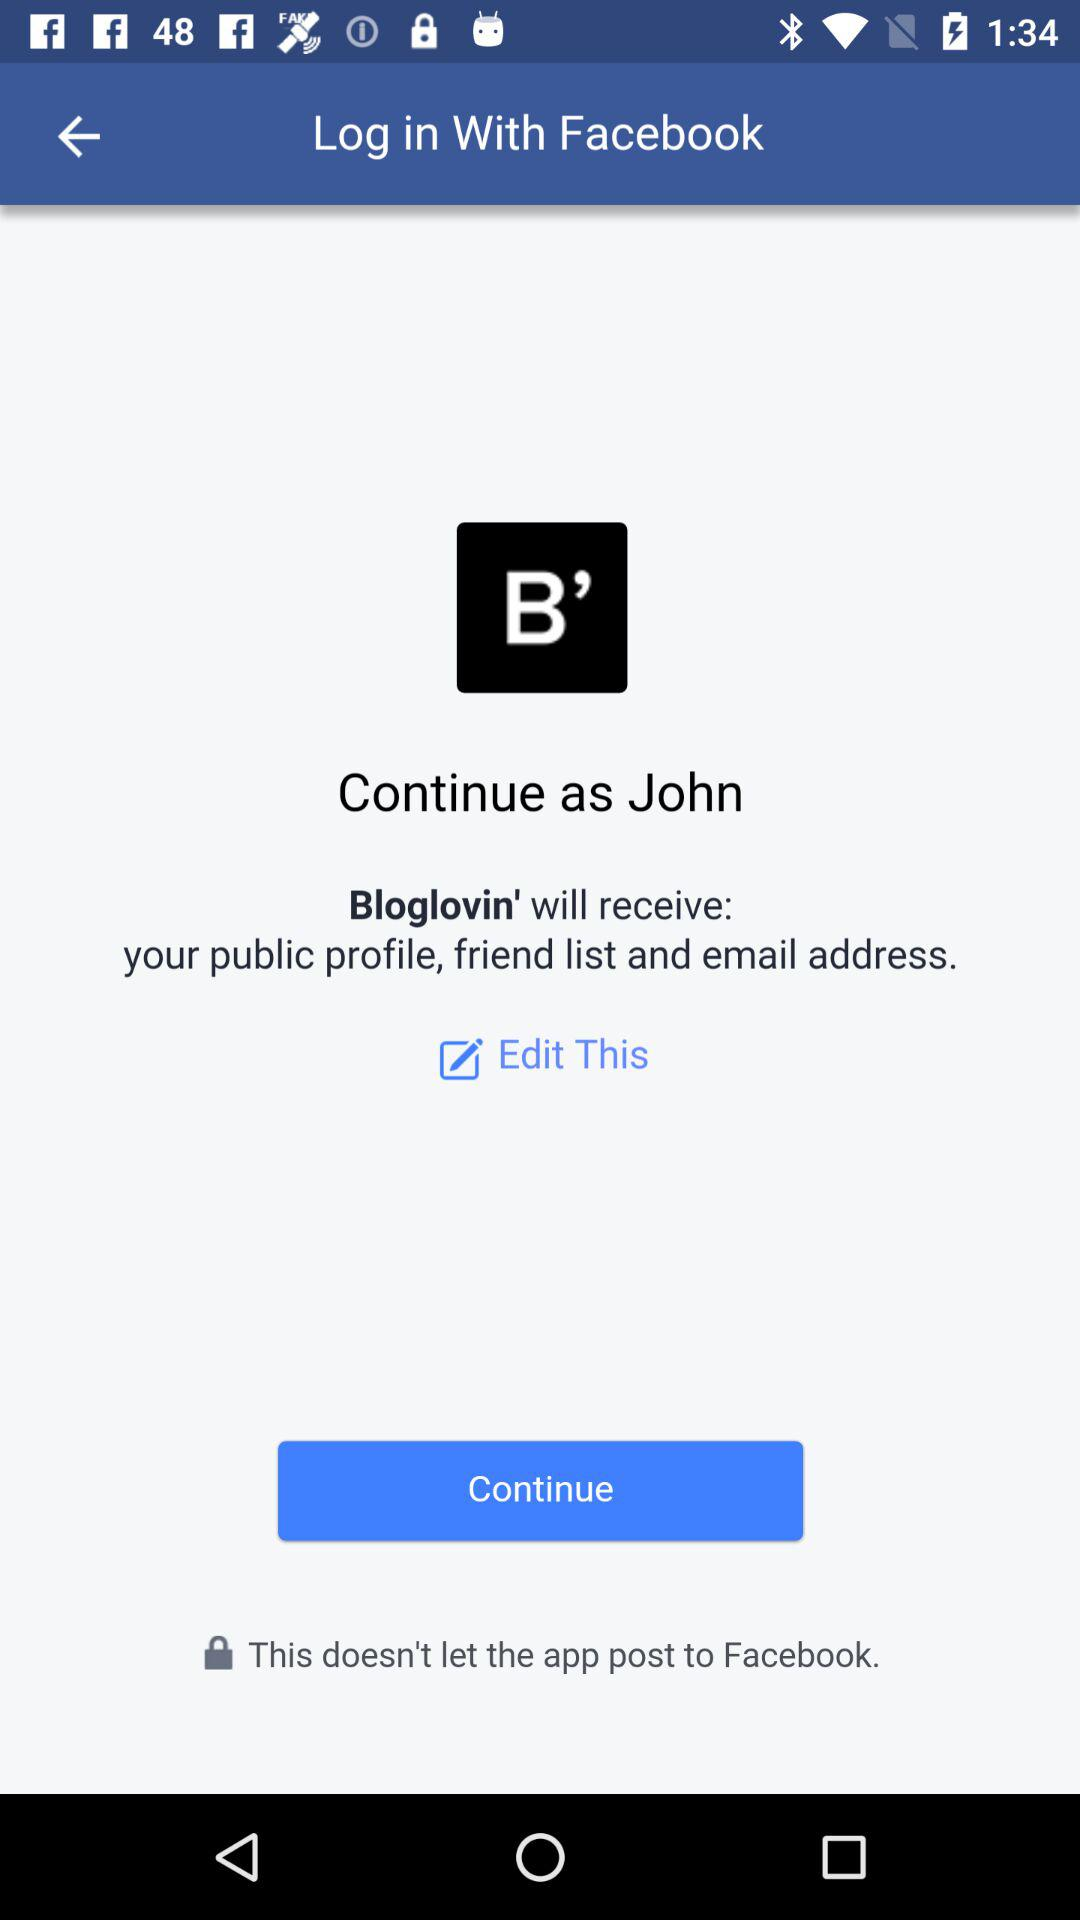What is the name of the user? The name of the user is John. 